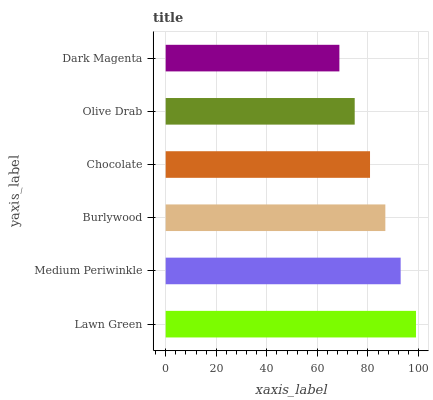Is Dark Magenta the minimum?
Answer yes or no. Yes. Is Lawn Green the maximum?
Answer yes or no. Yes. Is Medium Periwinkle the minimum?
Answer yes or no. No. Is Medium Periwinkle the maximum?
Answer yes or no. No. Is Lawn Green greater than Medium Periwinkle?
Answer yes or no. Yes. Is Medium Periwinkle less than Lawn Green?
Answer yes or no. Yes. Is Medium Periwinkle greater than Lawn Green?
Answer yes or no. No. Is Lawn Green less than Medium Periwinkle?
Answer yes or no. No. Is Burlywood the high median?
Answer yes or no. Yes. Is Chocolate the low median?
Answer yes or no. Yes. Is Olive Drab the high median?
Answer yes or no. No. Is Burlywood the low median?
Answer yes or no. No. 